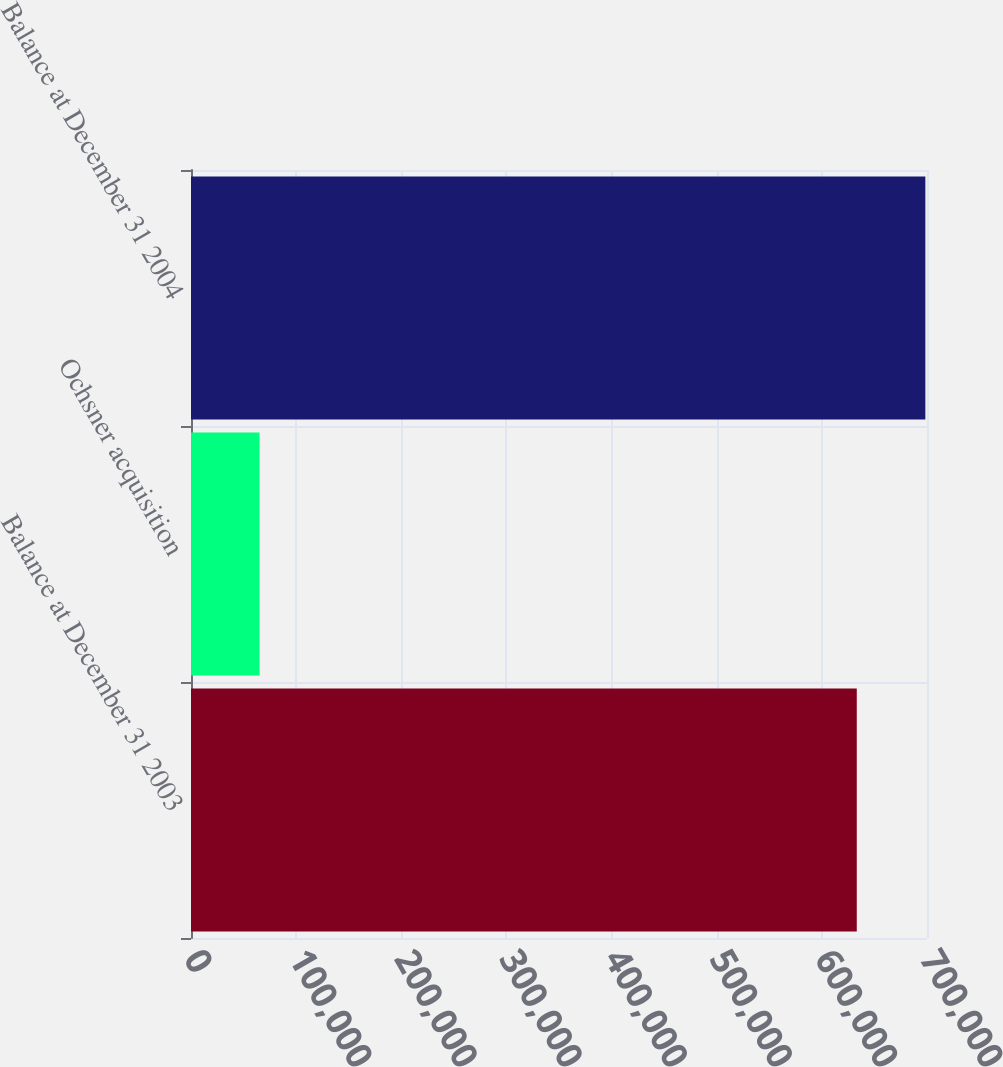<chart> <loc_0><loc_0><loc_500><loc_500><bar_chart><fcel>Balance at December 31 2003<fcel>Ochsner acquisition<fcel>Balance at December 31 2004<nl><fcel>633211<fcel>65219<fcel>698430<nl></chart> 